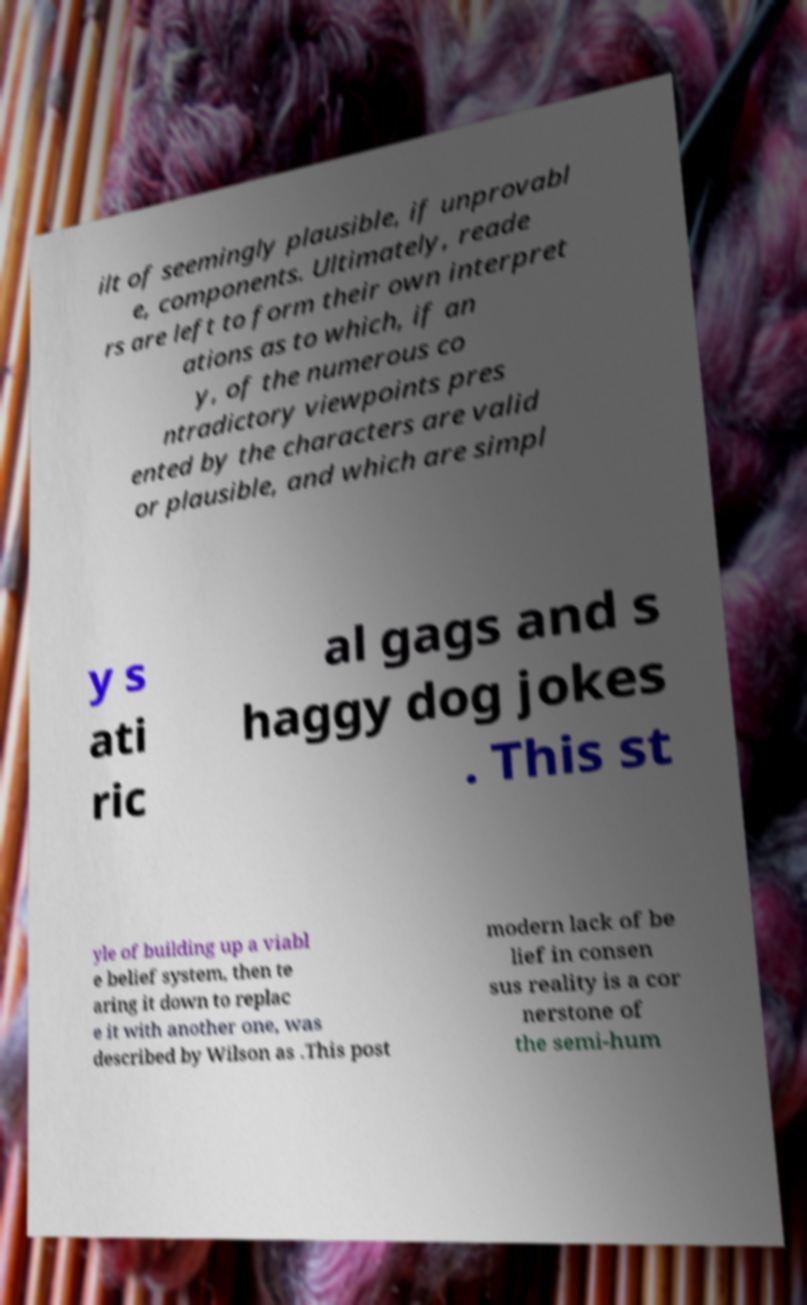For documentation purposes, I need the text within this image transcribed. Could you provide that? ilt of seemingly plausible, if unprovabl e, components. Ultimately, reade rs are left to form their own interpret ations as to which, if an y, of the numerous co ntradictory viewpoints pres ented by the characters are valid or plausible, and which are simpl y s ati ric al gags and s haggy dog jokes . This st yle of building up a viabl e belief system, then te aring it down to replac e it with another one, was described by Wilson as .This post modern lack of be lief in consen sus reality is a cor nerstone of the semi-hum 